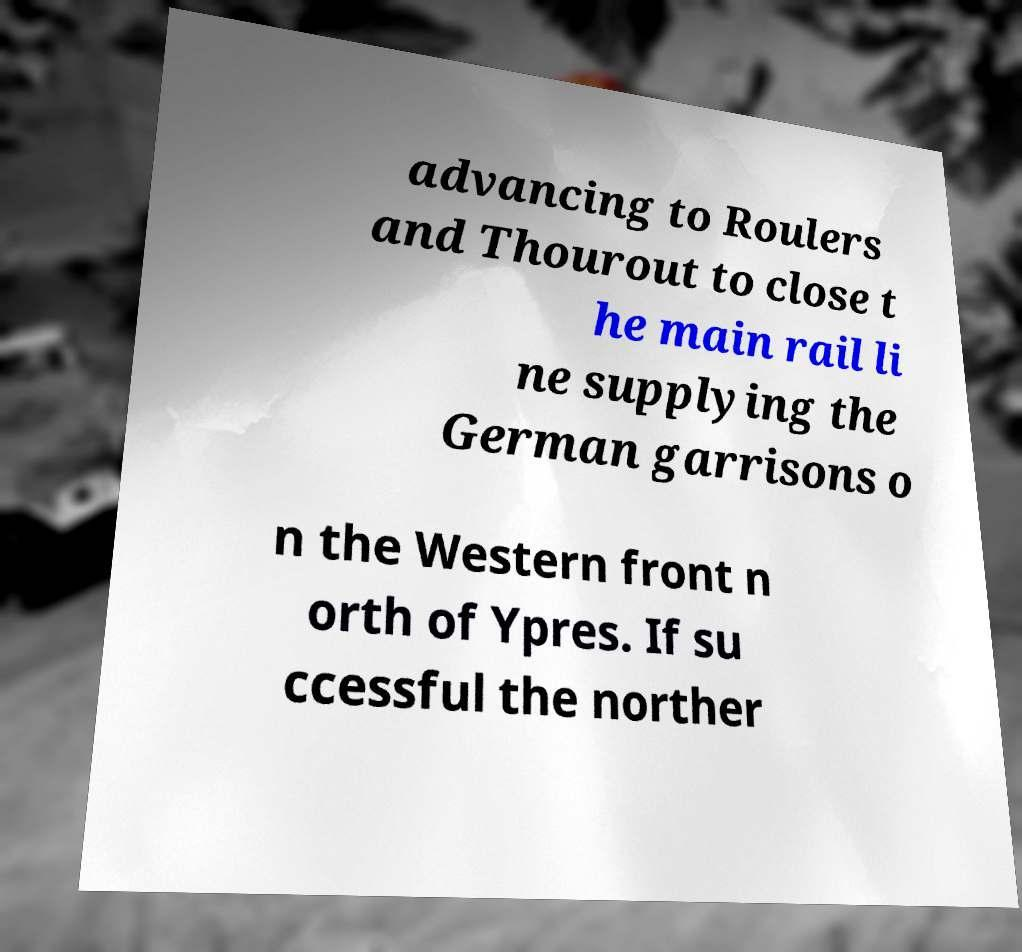Could you assist in decoding the text presented in this image and type it out clearly? advancing to Roulers and Thourout to close t he main rail li ne supplying the German garrisons o n the Western front n orth of Ypres. If su ccessful the norther 